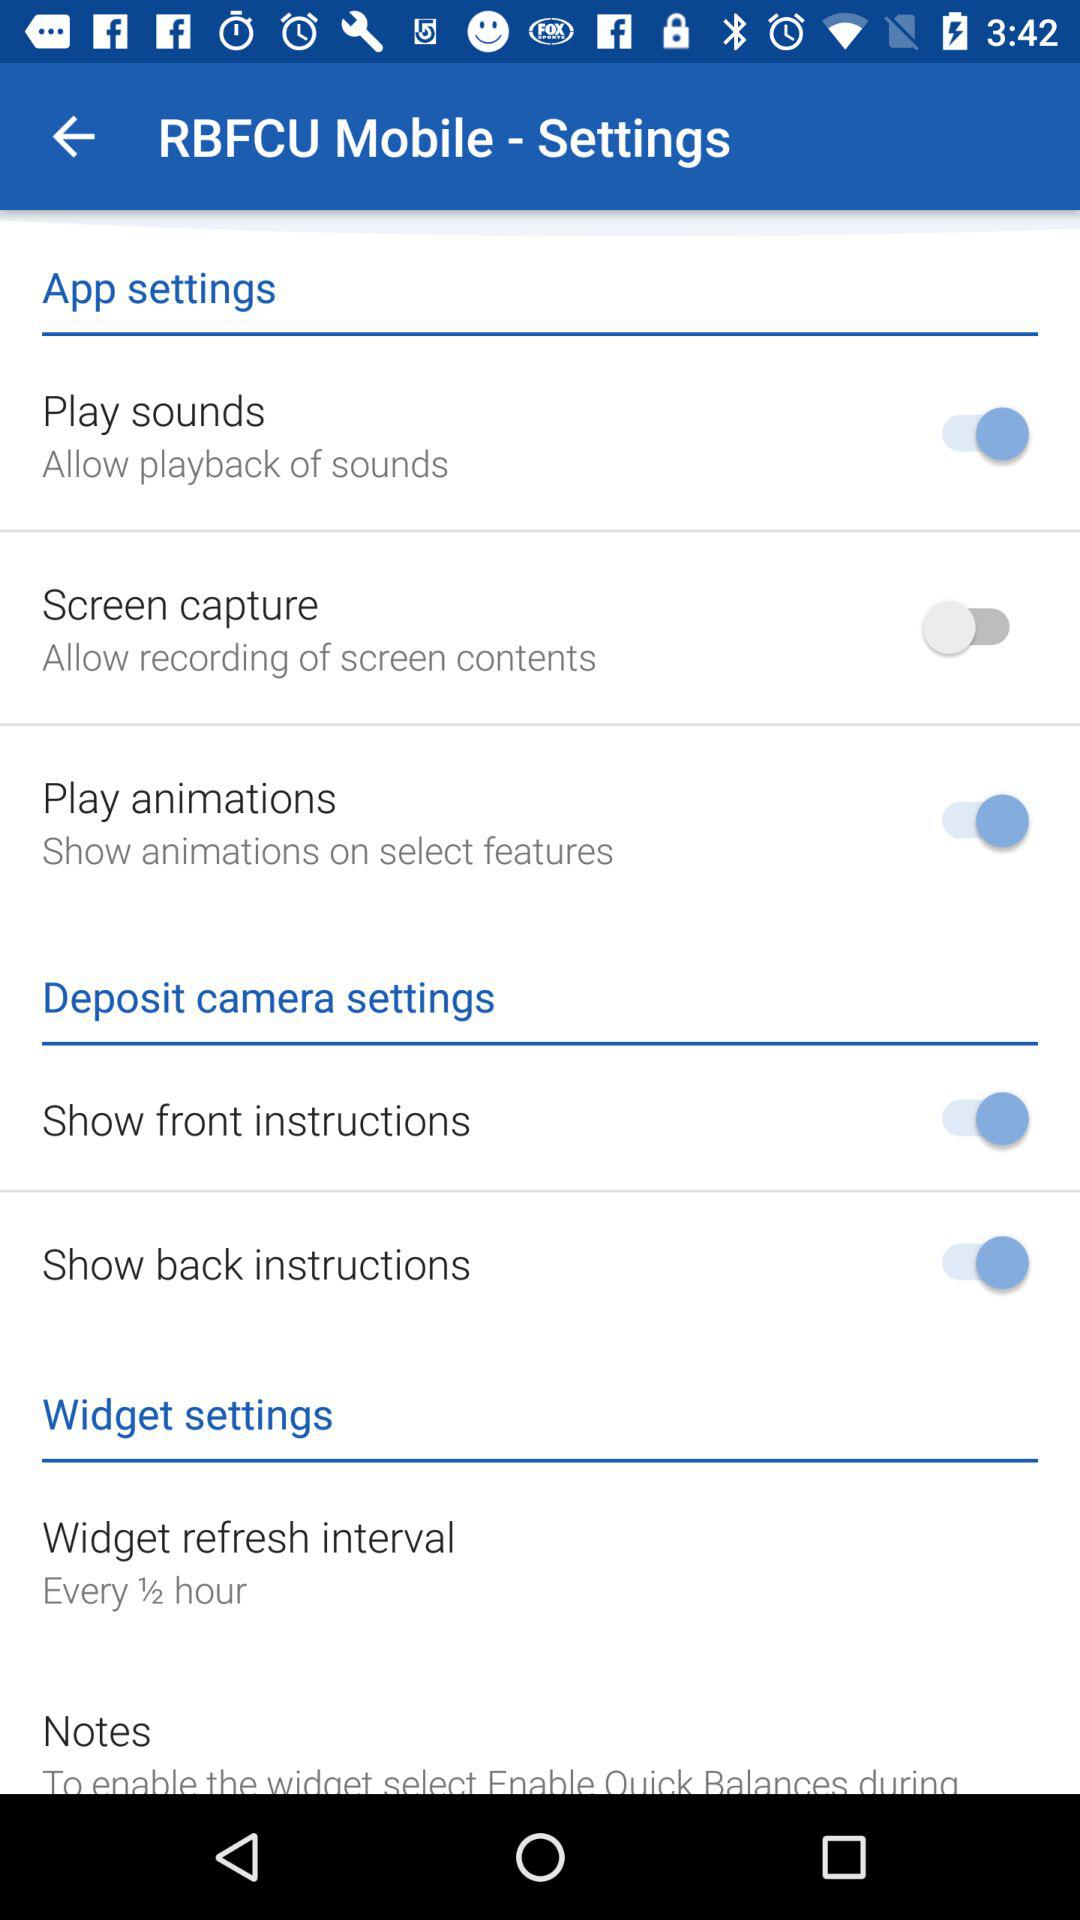What is the status of the "Play sounds"? The status is "on". 